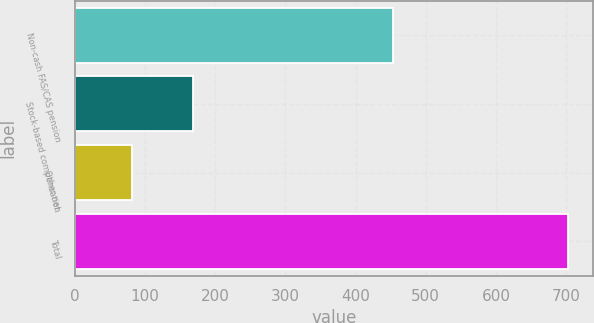Convert chart to OTSL. <chart><loc_0><loc_0><loc_500><loc_500><bar_chart><fcel>Non-cash FAS/CAS pension<fcel>Stock-based compensation<fcel>Other net<fcel>Total<nl><fcel>454<fcel>168<fcel>81<fcel>703<nl></chart> 